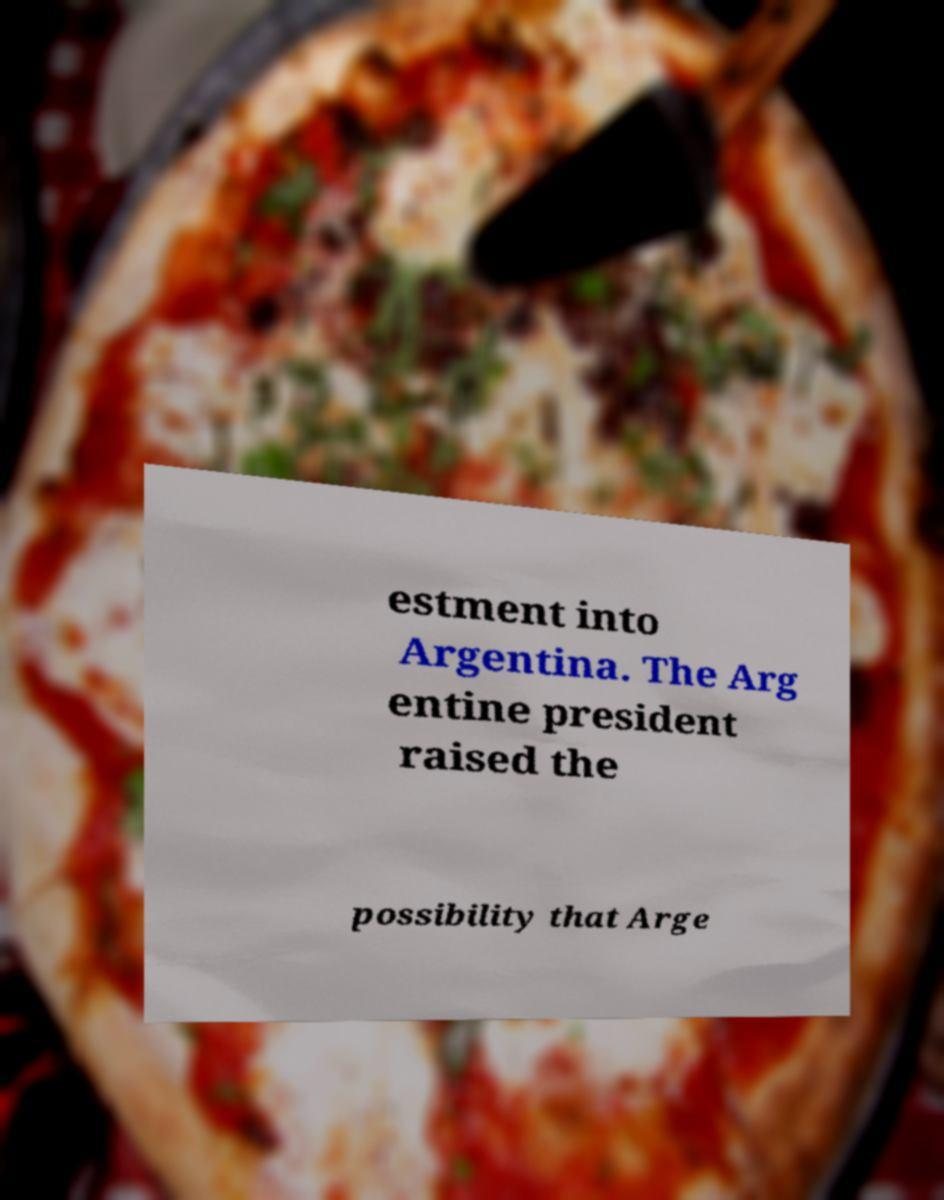There's text embedded in this image that I need extracted. Can you transcribe it verbatim? estment into Argentina. The Arg entine president raised the possibility that Arge 